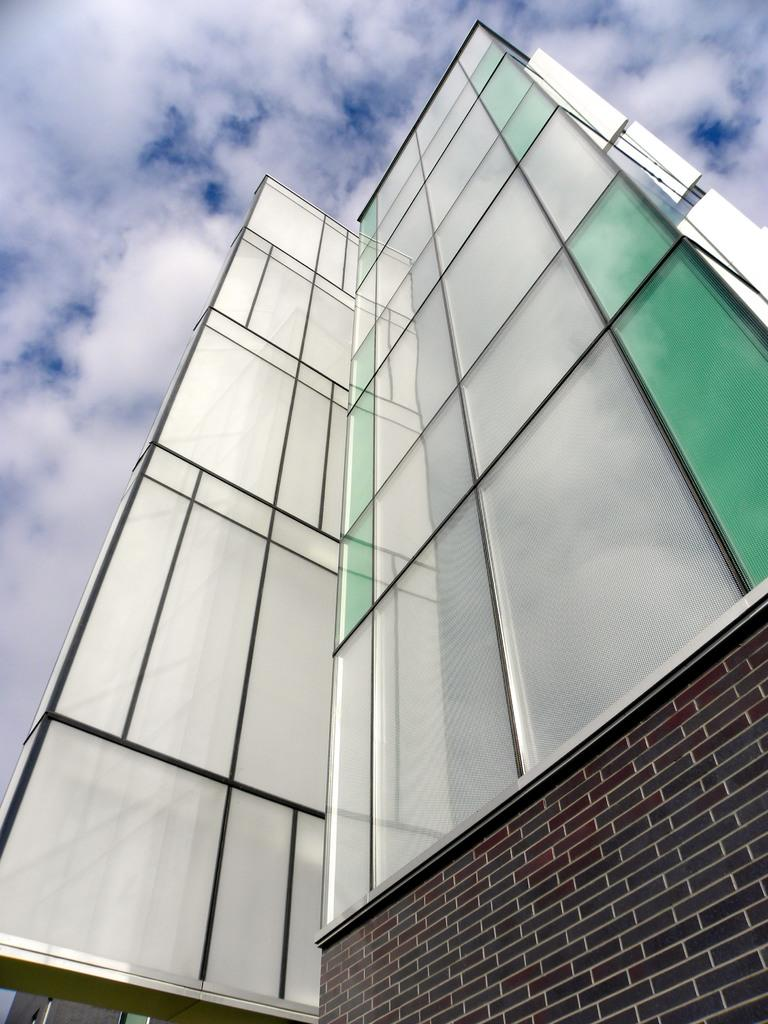What type of structure is present in the image? There is a building in the image. What can be seen in the background of the image? The sky is visible in the background of the image. How many twigs are attached to the building in the image? There are no twigs present on the building in the image. What type of coastline can be seen in the image? There is no coastline visible in the image; it features a building and the sky. 